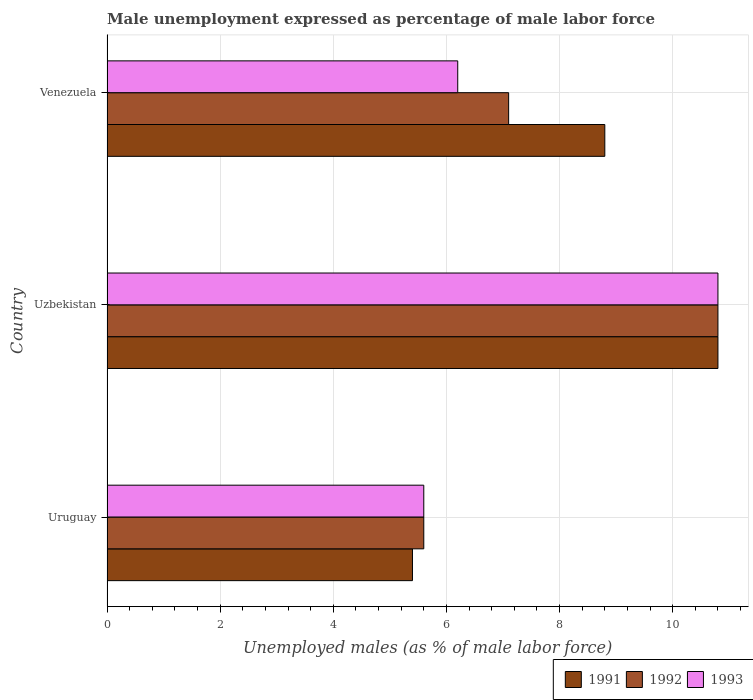Are the number of bars on each tick of the Y-axis equal?
Ensure brevity in your answer.  Yes. How many bars are there on the 2nd tick from the top?
Your answer should be compact. 3. How many bars are there on the 2nd tick from the bottom?
Make the answer very short. 3. What is the label of the 1st group of bars from the top?
Offer a very short reply. Venezuela. In how many cases, is the number of bars for a given country not equal to the number of legend labels?
Offer a very short reply. 0. What is the unemployment in males in in 1993 in Uruguay?
Make the answer very short. 5.6. Across all countries, what is the maximum unemployment in males in in 1993?
Keep it short and to the point. 10.8. Across all countries, what is the minimum unemployment in males in in 1993?
Offer a terse response. 5.6. In which country was the unemployment in males in in 1992 maximum?
Give a very brief answer. Uzbekistan. In which country was the unemployment in males in in 1992 minimum?
Make the answer very short. Uruguay. What is the total unemployment in males in in 1993 in the graph?
Provide a succinct answer. 22.6. What is the difference between the unemployment in males in in 1992 in Uzbekistan and that in Venezuela?
Keep it short and to the point. 3.7. What is the difference between the unemployment in males in in 1993 in Venezuela and the unemployment in males in in 1991 in Uruguay?
Keep it short and to the point. 0.8. What is the average unemployment in males in in 1991 per country?
Offer a terse response. 8.33. What is the difference between the unemployment in males in in 1991 and unemployment in males in in 1993 in Venezuela?
Ensure brevity in your answer.  2.6. What is the ratio of the unemployment in males in in 1992 in Uzbekistan to that in Venezuela?
Offer a terse response. 1.52. What is the difference between the highest and the second highest unemployment in males in in 1992?
Offer a terse response. 3.7. What is the difference between the highest and the lowest unemployment in males in in 1993?
Keep it short and to the point. 5.2. Is the sum of the unemployment in males in in 1993 in Uruguay and Uzbekistan greater than the maximum unemployment in males in in 1991 across all countries?
Ensure brevity in your answer.  Yes. What does the 3rd bar from the bottom in Venezuela represents?
Offer a terse response. 1993. Is it the case that in every country, the sum of the unemployment in males in in 1991 and unemployment in males in in 1992 is greater than the unemployment in males in in 1993?
Your answer should be very brief. Yes. How many bars are there?
Ensure brevity in your answer.  9. Are all the bars in the graph horizontal?
Your answer should be very brief. Yes. What is the title of the graph?
Offer a terse response. Male unemployment expressed as percentage of male labor force. Does "2012" appear as one of the legend labels in the graph?
Provide a succinct answer. No. What is the label or title of the X-axis?
Make the answer very short. Unemployed males (as % of male labor force). What is the label or title of the Y-axis?
Offer a very short reply. Country. What is the Unemployed males (as % of male labor force) in 1991 in Uruguay?
Provide a short and direct response. 5.4. What is the Unemployed males (as % of male labor force) in 1992 in Uruguay?
Provide a succinct answer. 5.6. What is the Unemployed males (as % of male labor force) in 1993 in Uruguay?
Offer a terse response. 5.6. What is the Unemployed males (as % of male labor force) of 1991 in Uzbekistan?
Your answer should be compact. 10.8. What is the Unemployed males (as % of male labor force) in 1992 in Uzbekistan?
Give a very brief answer. 10.8. What is the Unemployed males (as % of male labor force) in 1993 in Uzbekistan?
Your answer should be very brief. 10.8. What is the Unemployed males (as % of male labor force) of 1991 in Venezuela?
Offer a very short reply. 8.8. What is the Unemployed males (as % of male labor force) of 1992 in Venezuela?
Provide a short and direct response. 7.1. What is the Unemployed males (as % of male labor force) in 1993 in Venezuela?
Give a very brief answer. 6.2. Across all countries, what is the maximum Unemployed males (as % of male labor force) of 1991?
Offer a terse response. 10.8. Across all countries, what is the maximum Unemployed males (as % of male labor force) in 1992?
Keep it short and to the point. 10.8. Across all countries, what is the maximum Unemployed males (as % of male labor force) of 1993?
Offer a very short reply. 10.8. Across all countries, what is the minimum Unemployed males (as % of male labor force) of 1991?
Ensure brevity in your answer.  5.4. Across all countries, what is the minimum Unemployed males (as % of male labor force) in 1992?
Keep it short and to the point. 5.6. Across all countries, what is the minimum Unemployed males (as % of male labor force) of 1993?
Provide a short and direct response. 5.6. What is the total Unemployed males (as % of male labor force) of 1991 in the graph?
Your answer should be compact. 25. What is the total Unemployed males (as % of male labor force) in 1992 in the graph?
Give a very brief answer. 23.5. What is the total Unemployed males (as % of male labor force) in 1993 in the graph?
Offer a terse response. 22.6. What is the difference between the Unemployed males (as % of male labor force) in 1991 in Uruguay and that in Venezuela?
Give a very brief answer. -3.4. What is the difference between the Unemployed males (as % of male labor force) in 1992 in Uzbekistan and that in Venezuela?
Offer a very short reply. 3.7. What is the difference between the Unemployed males (as % of male labor force) in 1992 in Uruguay and the Unemployed males (as % of male labor force) in 1993 in Uzbekistan?
Ensure brevity in your answer.  -5.2. What is the difference between the Unemployed males (as % of male labor force) of 1991 in Uruguay and the Unemployed males (as % of male labor force) of 1993 in Venezuela?
Your answer should be very brief. -0.8. What is the difference between the Unemployed males (as % of male labor force) in 1991 in Uzbekistan and the Unemployed males (as % of male labor force) in 1993 in Venezuela?
Make the answer very short. 4.6. What is the difference between the Unemployed males (as % of male labor force) in 1992 in Uzbekistan and the Unemployed males (as % of male labor force) in 1993 in Venezuela?
Your answer should be very brief. 4.6. What is the average Unemployed males (as % of male labor force) of 1991 per country?
Your answer should be compact. 8.33. What is the average Unemployed males (as % of male labor force) in 1992 per country?
Ensure brevity in your answer.  7.83. What is the average Unemployed males (as % of male labor force) of 1993 per country?
Make the answer very short. 7.53. What is the difference between the Unemployed males (as % of male labor force) in 1992 and Unemployed males (as % of male labor force) in 1993 in Uruguay?
Make the answer very short. 0. What is the difference between the Unemployed males (as % of male labor force) in 1991 and Unemployed males (as % of male labor force) in 1992 in Uzbekistan?
Offer a very short reply. 0. What is the difference between the Unemployed males (as % of male labor force) of 1991 and Unemployed males (as % of male labor force) of 1992 in Venezuela?
Provide a succinct answer. 1.7. What is the ratio of the Unemployed males (as % of male labor force) in 1991 in Uruguay to that in Uzbekistan?
Keep it short and to the point. 0.5. What is the ratio of the Unemployed males (as % of male labor force) of 1992 in Uruguay to that in Uzbekistan?
Provide a succinct answer. 0.52. What is the ratio of the Unemployed males (as % of male labor force) in 1993 in Uruguay to that in Uzbekistan?
Your answer should be compact. 0.52. What is the ratio of the Unemployed males (as % of male labor force) of 1991 in Uruguay to that in Venezuela?
Ensure brevity in your answer.  0.61. What is the ratio of the Unemployed males (as % of male labor force) in 1992 in Uruguay to that in Venezuela?
Your answer should be compact. 0.79. What is the ratio of the Unemployed males (as % of male labor force) in 1993 in Uruguay to that in Venezuela?
Ensure brevity in your answer.  0.9. What is the ratio of the Unemployed males (as % of male labor force) of 1991 in Uzbekistan to that in Venezuela?
Your answer should be very brief. 1.23. What is the ratio of the Unemployed males (as % of male labor force) in 1992 in Uzbekistan to that in Venezuela?
Offer a terse response. 1.52. What is the ratio of the Unemployed males (as % of male labor force) of 1993 in Uzbekistan to that in Venezuela?
Ensure brevity in your answer.  1.74. What is the difference between the highest and the lowest Unemployed males (as % of male labor force) in 1992?
Provide a succinct answer. 5.2. What is the difference between the highest and the lowest Unemployed males (as % of male labor force) in 1993?
Give a very brief answer. 5.2. 